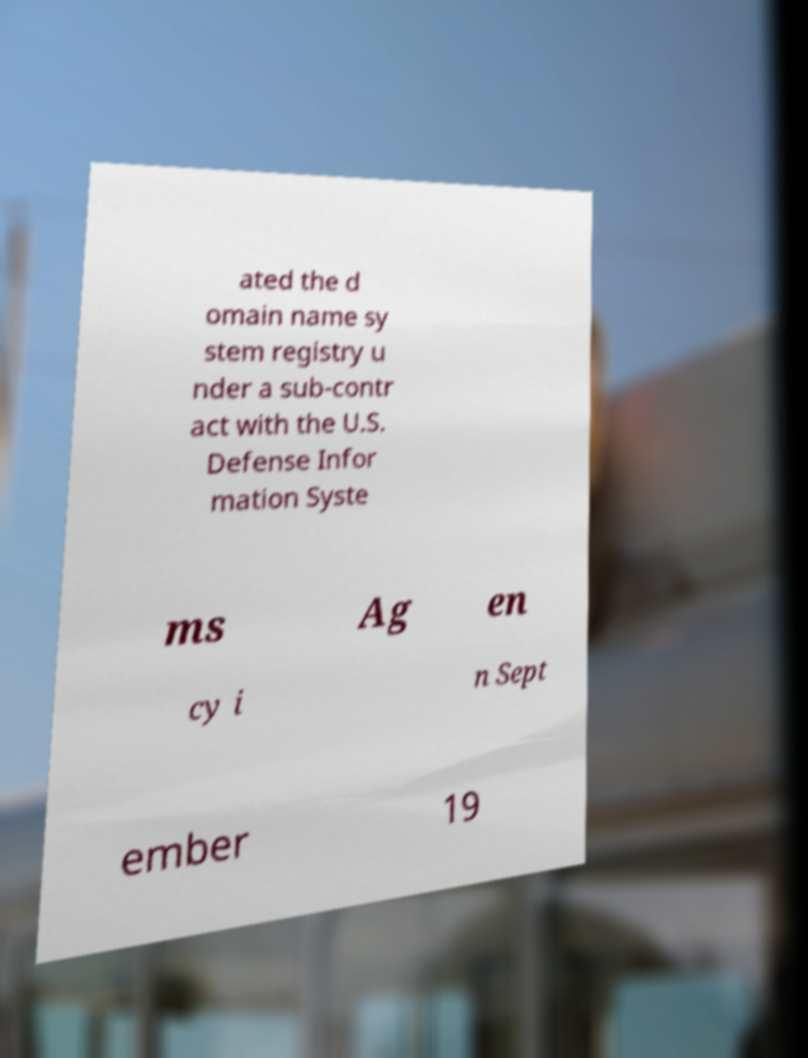Please read and relay the text visible in this image. What does it say? ated the d omain name sy stem registry u nder a sub-contr act with the U.S. Defense Infor mation Syste ms Ag en cy i n Sept ember 19 